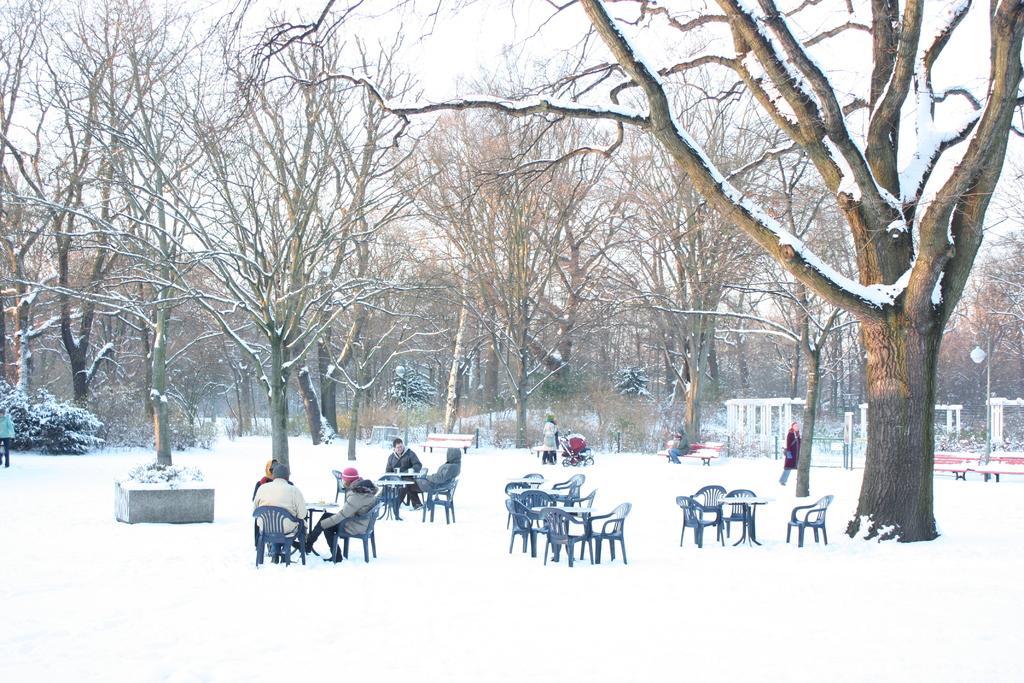Can you describe this image briefly? In the center of the image we can see tables and some persons are sitting on a chair. In the middle of the image we can see benches, some persons, trolley, arch, trees, plants, electric light pole. At the bottom of the image we can see the snow. At the top of the image we can see the sky. 